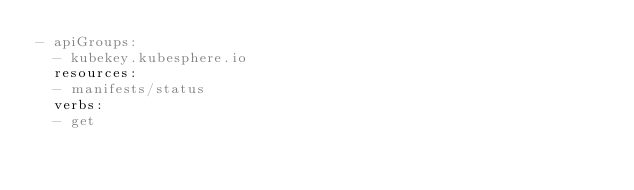<code> <loc_0><loc_0><loc_500><loc_500><_YAML_>- apiGroups:
  - kubekey.kubesphere.io
  resources:
  - manifests/status
  verbs:
  - get
</code> 